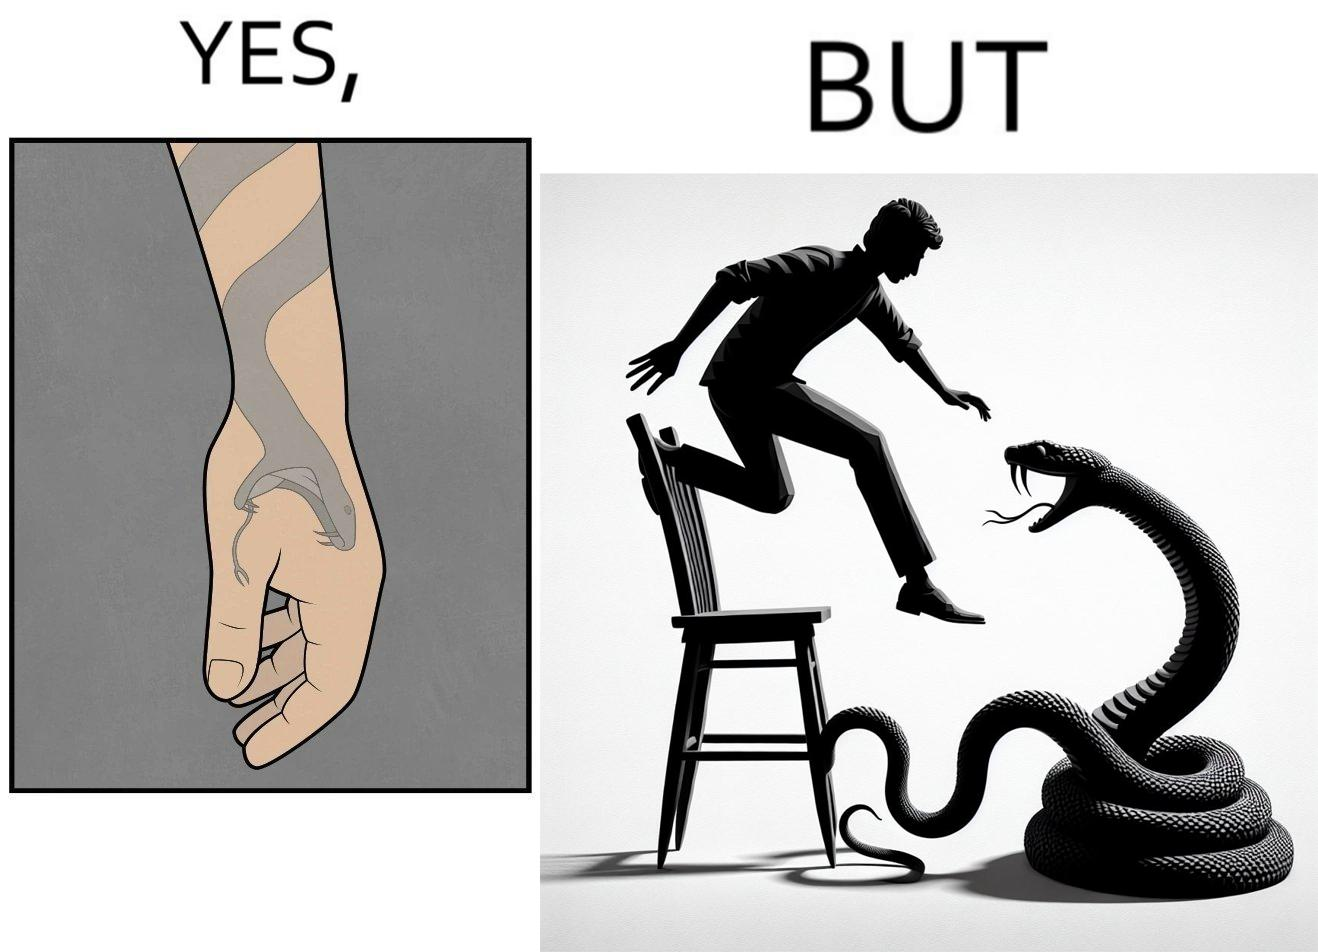Describe what you see in this image. The image is ironic, because in the first image the tattoo of a snake on someone's hand may give us a hint about how powerful or brave the person can be who is having this tattoo but in the second image the person with same tattoo is seen frightened due to a snake in his house 